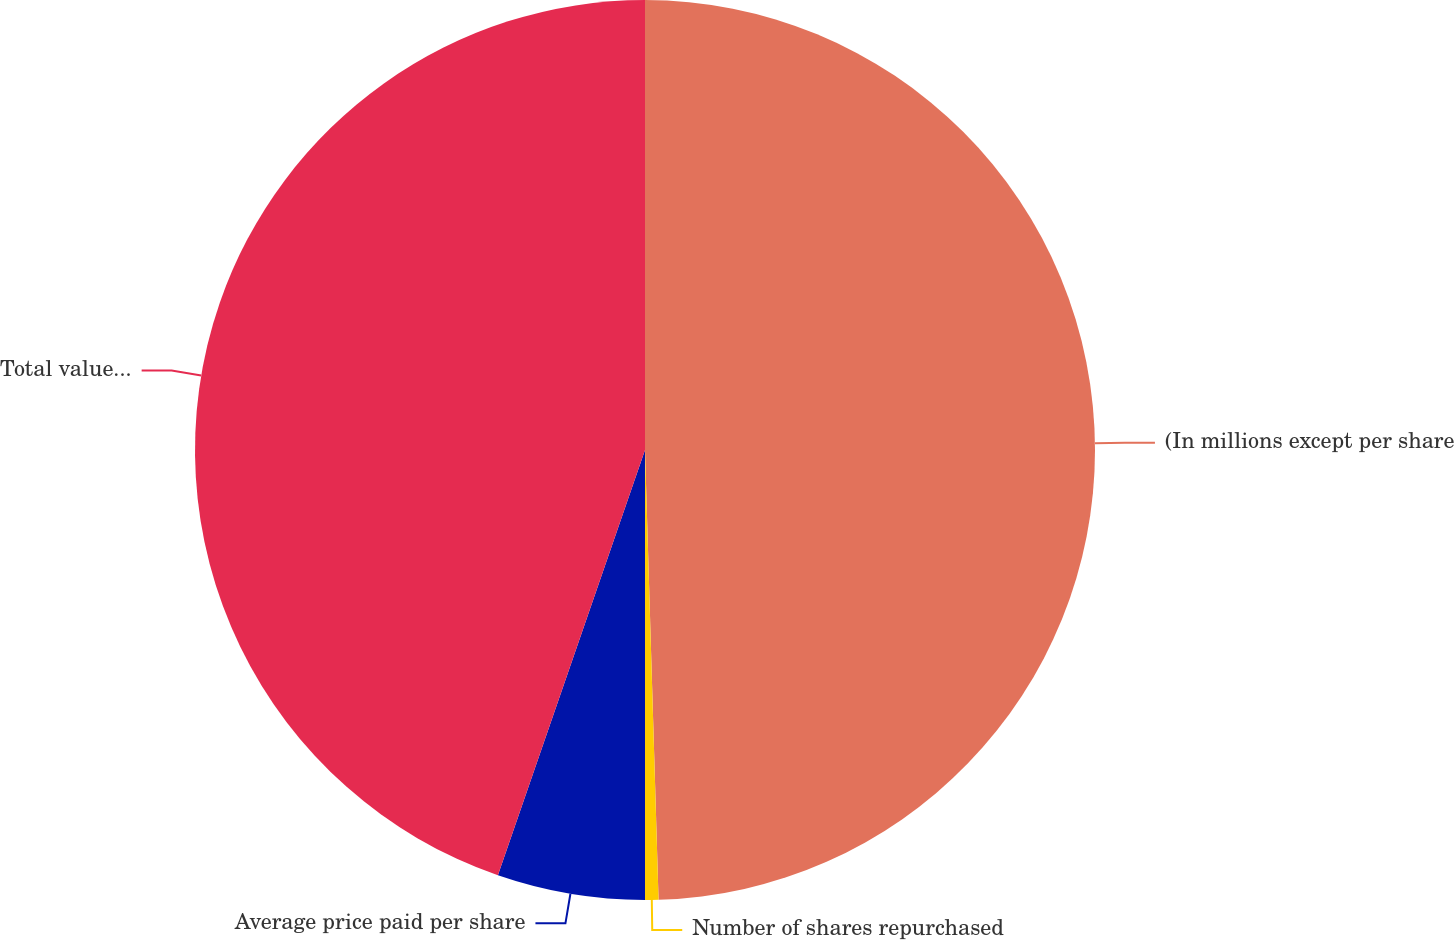<chart> <loc_0><loc_0><loc_500><loc_500><pie_chart><fcel>(In millions except per share<fcel>Number of shares repurchased<fcel>Average price paid per share<fcel>Total value of shares<nl><fcel>49.52%<fcel>0.48%<fcel>5.3%<fcel>44.7%<nl></chart> 